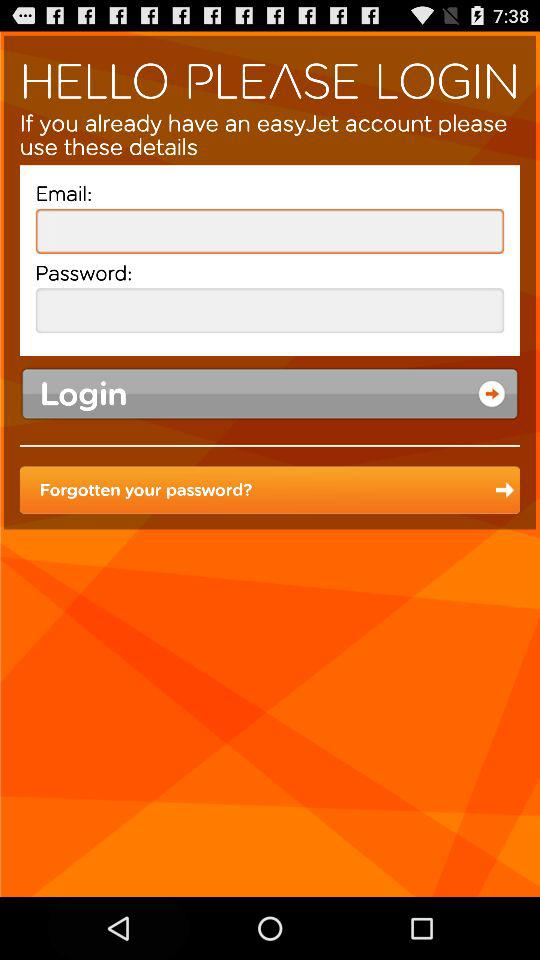What account is needed to log in? The account that is needed to log in is "easyJet". 